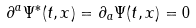<formula> <loc_0><loc_0><loc_500><loc_500>\partial ^ { a } \Psi ^ { * } ( t , x ) = \partial _ { a } \Psi ( t , x ) = 0</formula> 